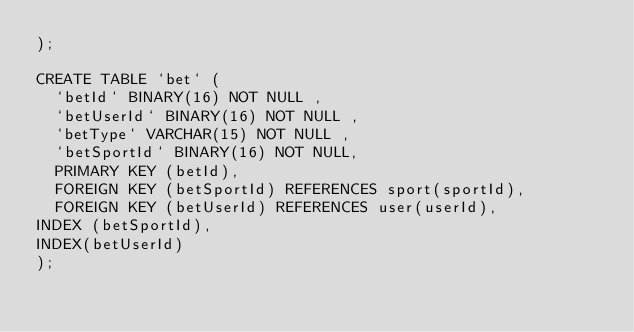<code> <loc_0><loc_0><loc_500><loc_500><_SQL_>);

CREATE TABLE `bet` (
	`betId` BINARY(16) NOT NULL ,
	`betUserId` BINARY(16) NOT NULL ,
	`betType` VARCHAR(15) NOT NULL ,
	`betSportId` BINARY(16) NOT NULL,
	PRIMARY KEY (betId),
	FOREIGN KEY (betSportId) REFERENCES sport(sportId),
	FOREIGN KEY (betUserId) REFERENCES user(userId),
INDEX (betSportId),
INDEX(betUserId)
);

</code> 